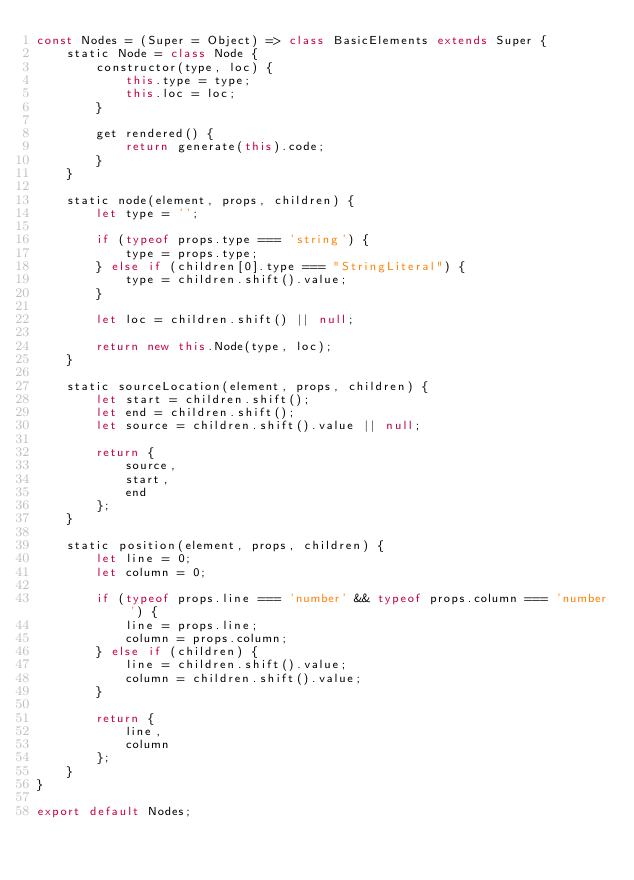<code> <loc_0><loc_0><loc_500><loc_500><_JavaScript_>const Nodes = (Super = Object) => class BasicElements extends Super {
    static Node = class Node {
        constructor(type, loc) {
            this.type = type;
            this.loc = loc;
        }

        get rendered() {
            return generate(this).code;
        }
    }

    static node(element, props, children) {
        let type = '';
        
        if (typeof props.type === 'string') {
            type = props.type;
        } else if (children[0].type === "StringLiteral") {
            type = children.shift().value;
        }

        let loc = children.shift() || null;

        return new this.Node(type, loc);
    }

    static sourceLocation(element, props, children) {
        let start = children.shift();
        let end = children.shift();
        let source = children.shift().value || null;

        return {
            source,
            start,
            end
        };
    }

    static position(element, props, children) {
        let line = 0;
        let column = 0;

        if (typeof props.line === 'number' && typeof props.column === 'number') {
            line = props.line;
            column = props.column;
        } else if (children) {
            line = children.shift().value;
            column = children.shift().value;
        }

        return {
            line,
            column
        };
    }
}

export default Nodes;</code> 